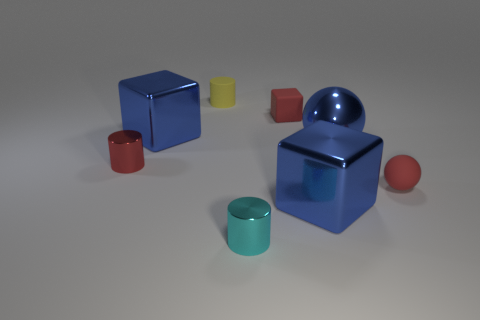There is a rubber block that is the same size as the cyan metallic thing; what color is it? The rubber block you're referring to is red in color. It's interesting to note that despite the similarity in size to the cyan metallic object, the matte texture of the rubber block offers a stark contrast to the reflective metal surface of the other object. 